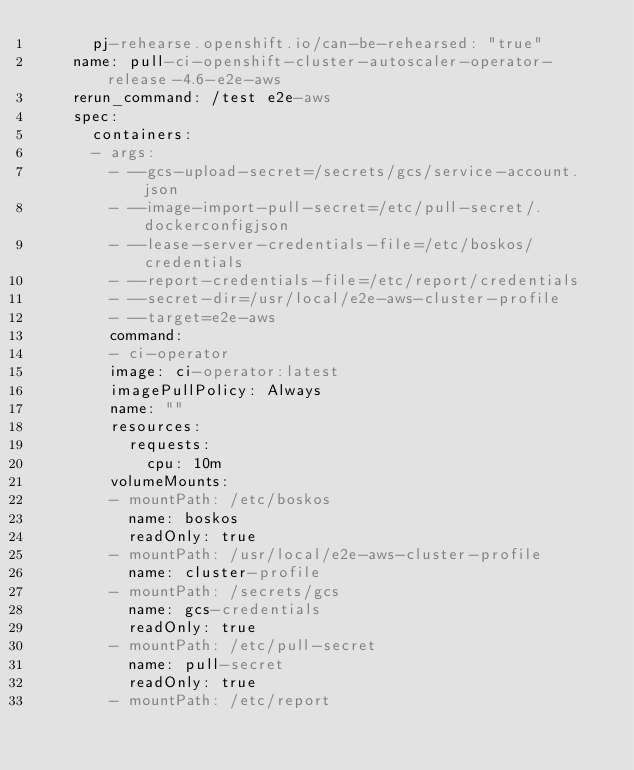<code> <loc_0><loc_0><loc_500><loc_500><_YAML_>      pj-rehearse.openshift.io/can-be-rehearsed: "true"
    name: pull-ci-openshift-cluster-autoscaler-operator-release-4.6-e2e-aws
    rerun_command: /test e2e-aws
    spec:
      containers:
      - args:
        - --gcs-upload-secret=/secrets/gcs/service-account.json
        - --image-import-pull-secret=/etc/pull-secret/.dockerconfigjson
        - --lease-server-credentials-file=/etc/boskos/credentials
        - --report-credentials-file=/etc/report/credentials
        - --secret-dir=/usr/local/e2e-aws-cluster-profile
        - --target=e2e-aws
        command:
        - ci-operator
        image: ci-operator:latest
        imagePullPolicy: Always
        name: ""
        resources:
          requests:
            cpu: 10m
        volumeMounts:
        - mountPath: /etc/boskos
          name: boskos
          readOnly: true
        - mountPath: /usr/local/e2e-aws-cluster-profile
          name: cluster-profile
        - mountPath: /secrets/gcs
          name: gcs-credentials
          readOnly: true
        - mountPath: /etc/pull-secret
          name: pull-secret
          readOnly: true
        - mountPath: /etc/report</code> 